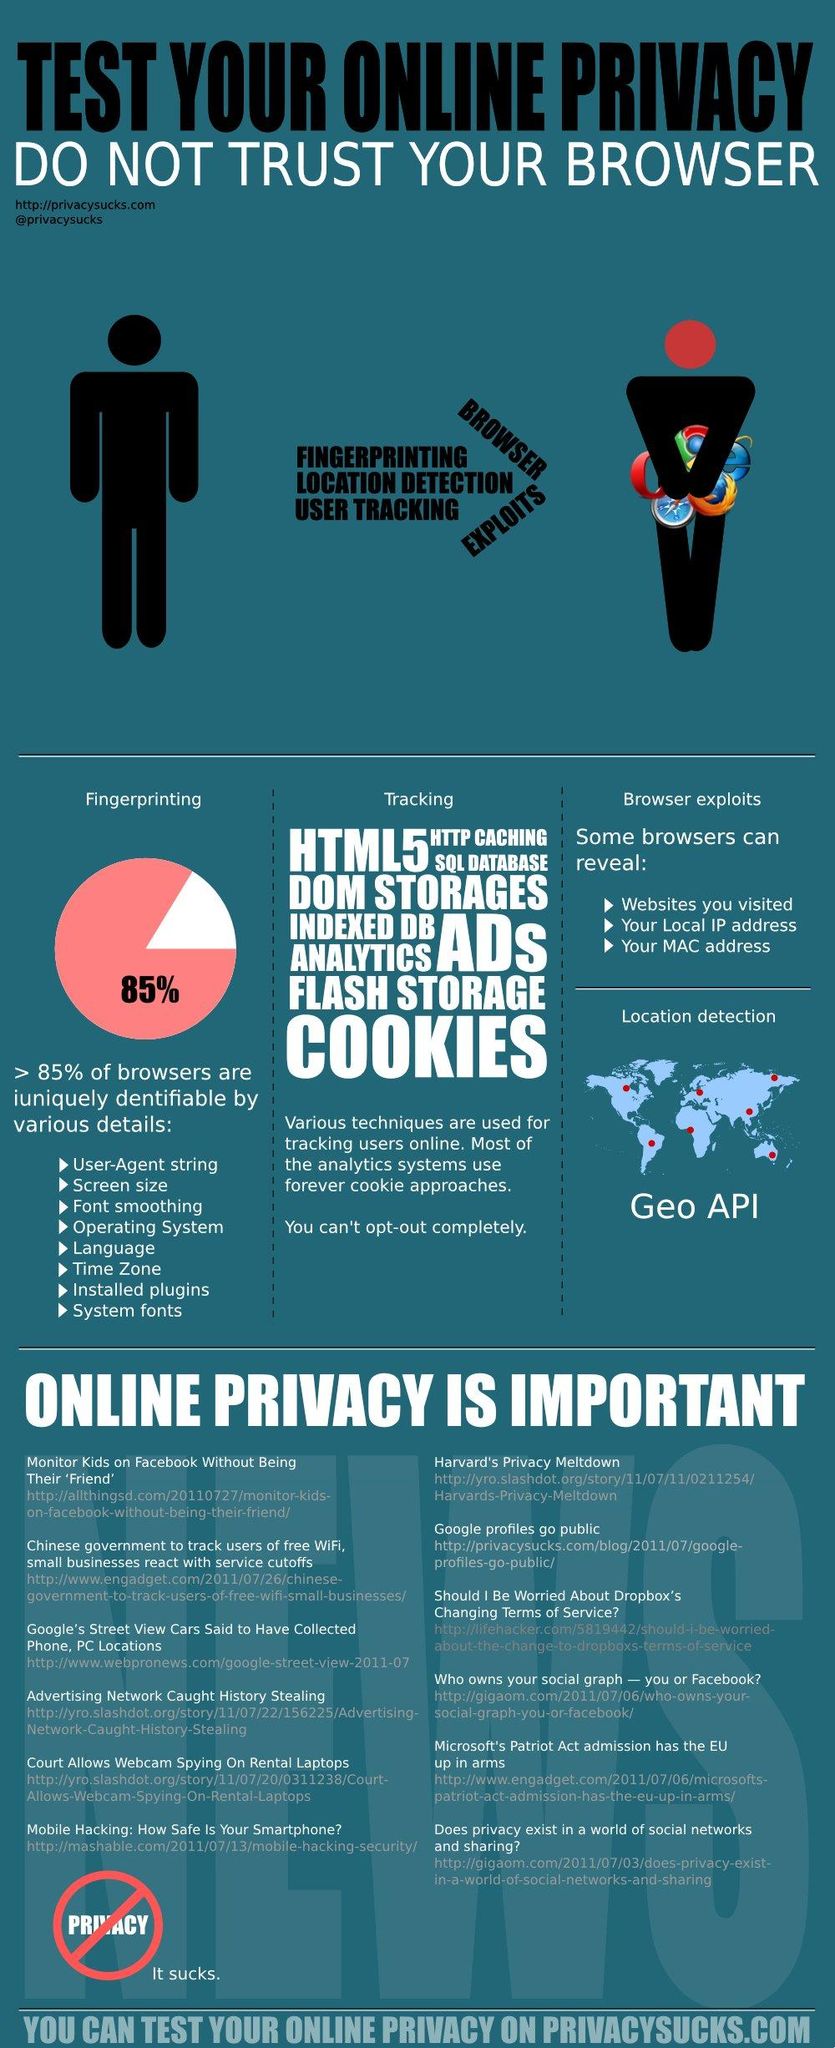Indicate a few pertinent items in this graphic. Online privacy can be compromised by various factors, including but not limited to browser exploits, fingerprinting, location detection, and user tracking. The Geo API is a tool that is designed to detect the location of a user through various means including GPS, network location, and other sources. The pie chart shows that 85% of the survey respondents reported experiencing a certain issue. 